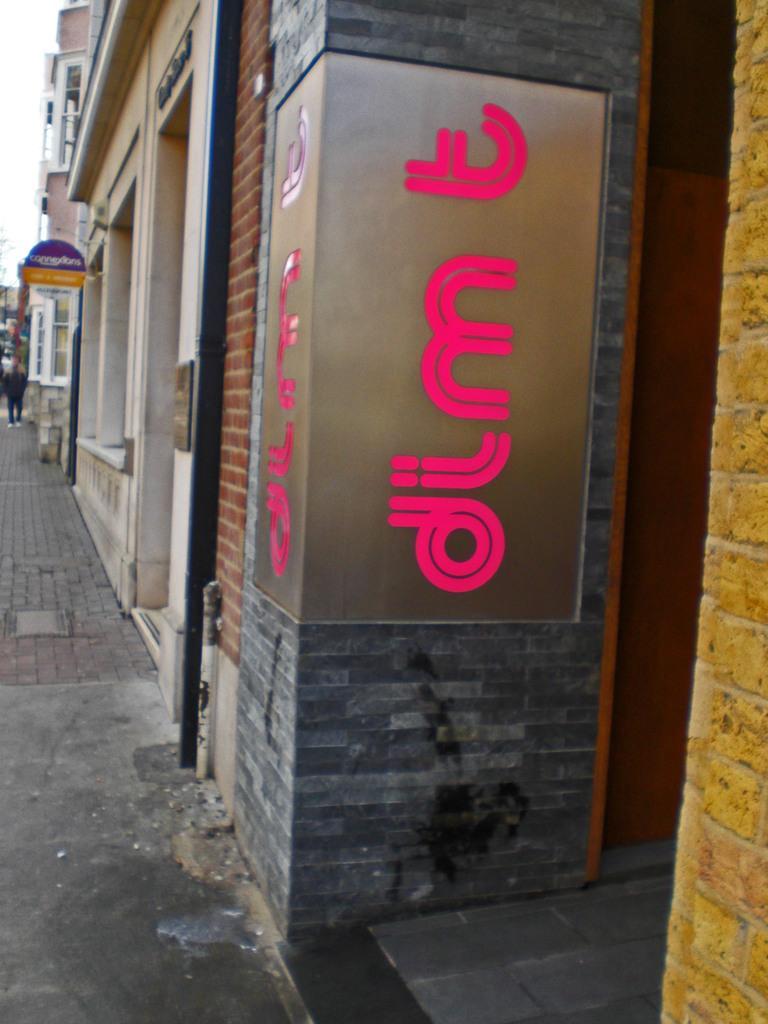Could you give a brief overview of what you see in this image? In this picture there are many shops and a advertising board in the front. Beside there is a cobbler stones on the ground. 